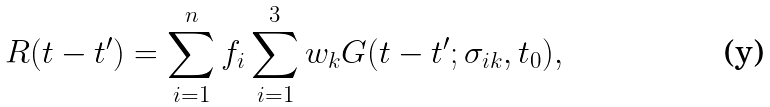<formula> <loc_0><loc_0><loc_500><loc_500>R ( t - t ^ { \prime } ) = \sum _ { i = 1 } ^ { n } f _ { i } \sum _ { i = 1 } ^ { 3 } w _ { k } G ( t - t ^ { \prime } ; \sigma _ { i k } , t _ { 0 } ) ,</formula> 